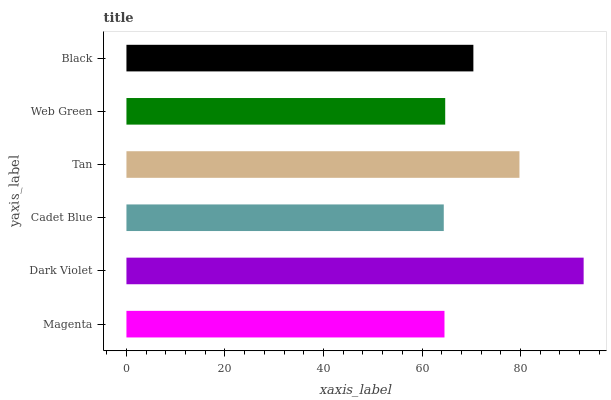Is Cadet Blue the minimum?
Answer yes or no. Yes. Is Dark Violet the maximum?
Answer yes or no. Yes. Is Dark Violet the minimum?
Answer yes or no. No. Is Cadet Blue the maximum?
Answer yes or no. No. Is Dark Violet greater than Cadet Blue?
Answer yes or no. Yes. Is Cadet Blue less than Dark Violet?
Answer yes or no. Yes. Is Cadet Blue greater than Dark Violet?
Answer yes or no. No. Is Dark Violet less than Cadet Blue?
Answer yes or no. No. Is Black the high median?
Answer yes or no. Yes. Is Web Green the low median?
Answer yes or no. Yes. Is Dark Violet the high median?
Answer yes or no. No. Is Tan the low median?
Answer yes or no. No. 